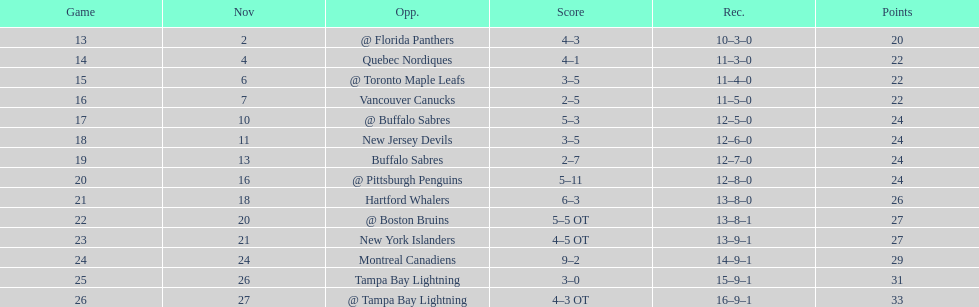What other team had the closest amount of wins? New York Islanders. 